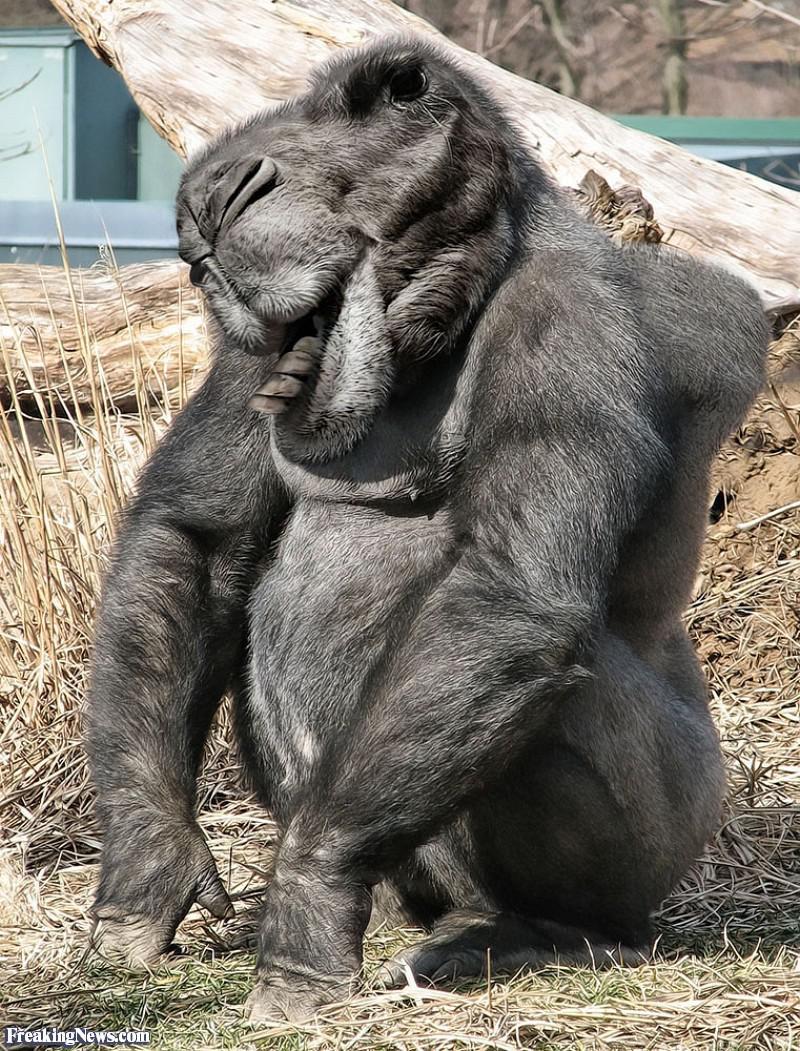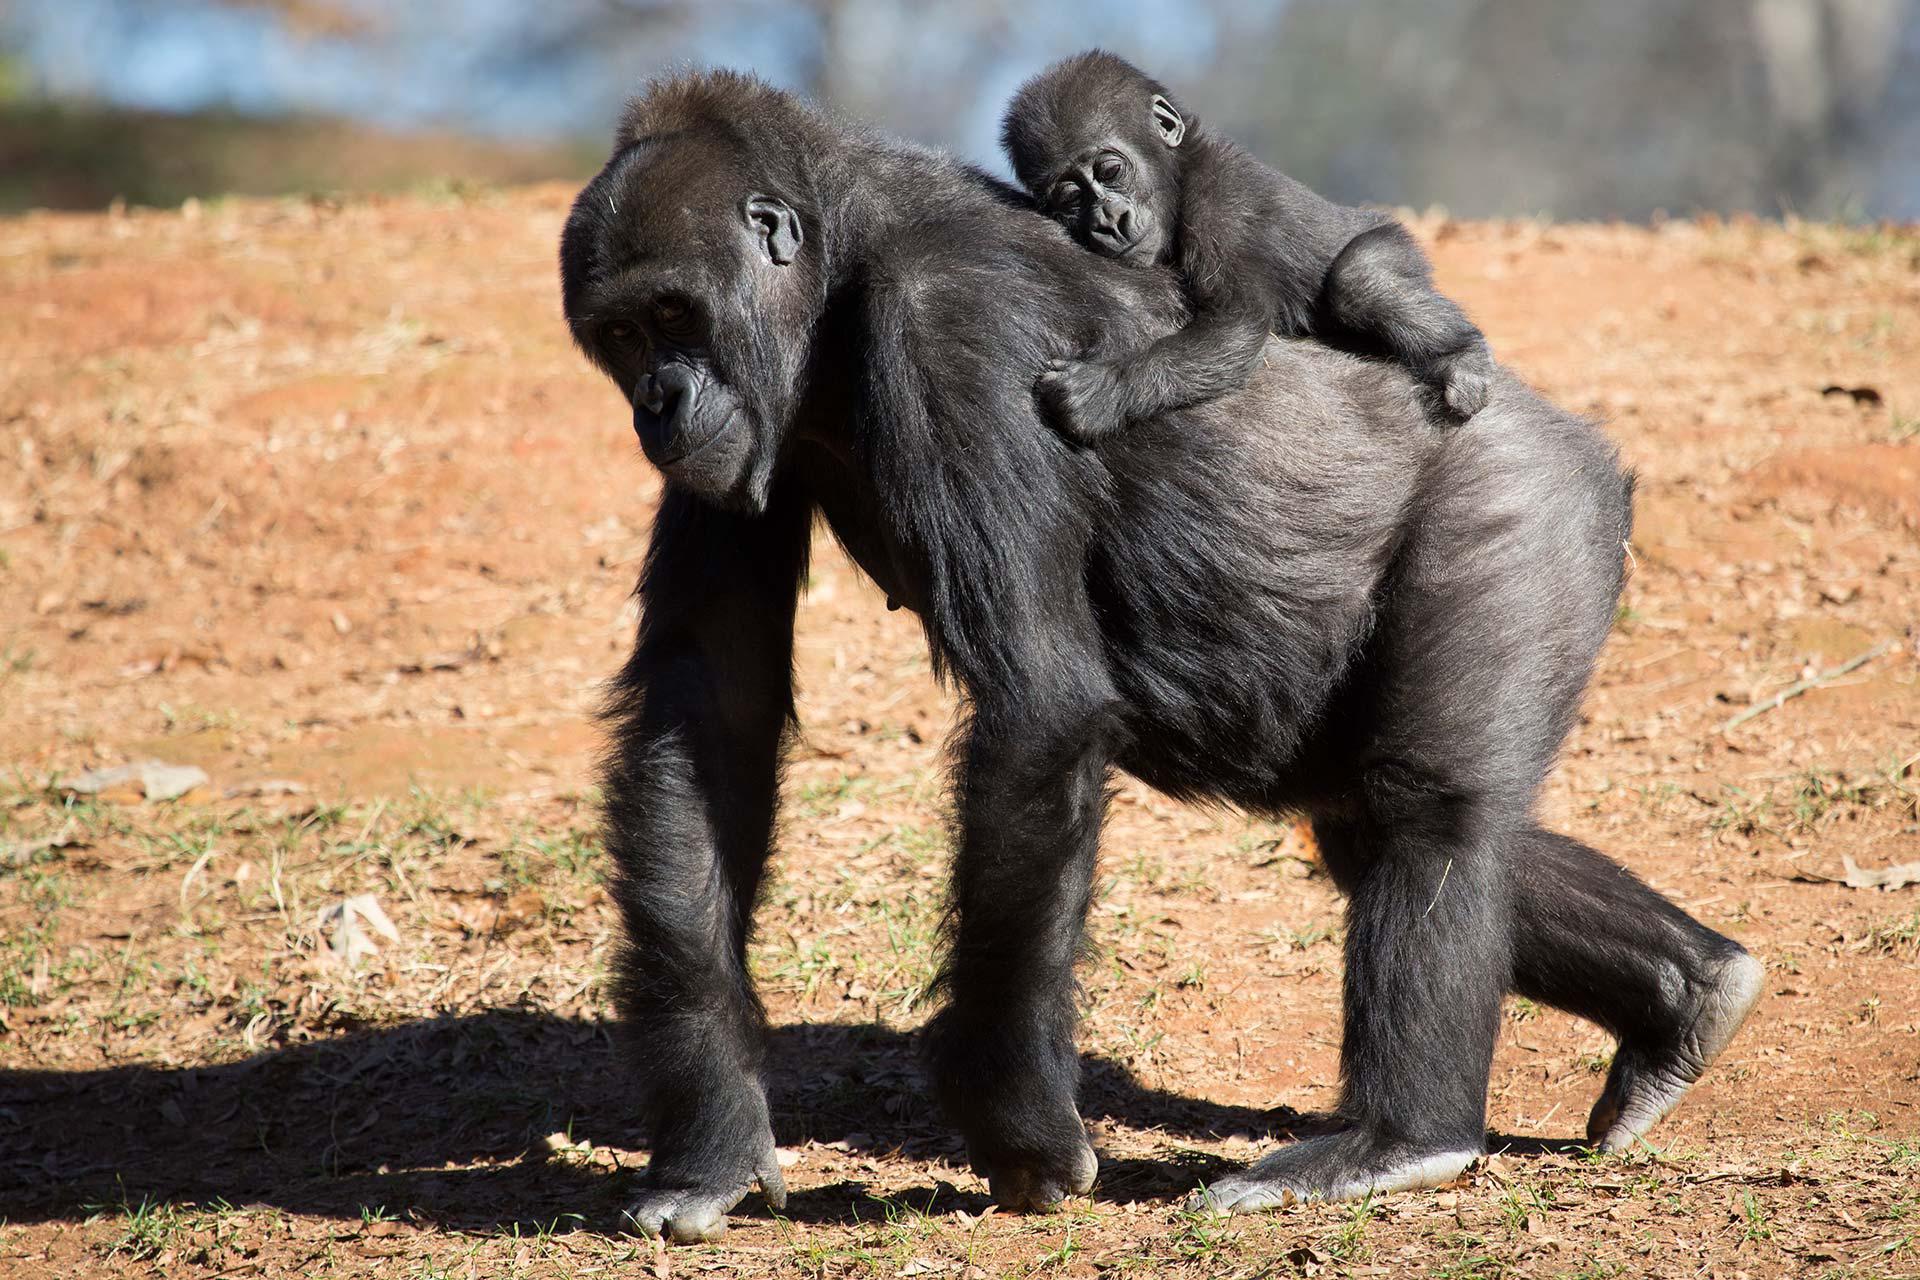The first image is the image on the left, the second image is the image on the right. For the images displayed, is the sentence "A baby monkey is riding on an adult in the image on the right." factually correct? Answer yes or no. Yes. 